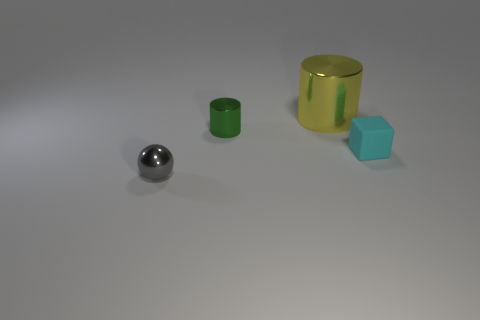Do the yellow thing and the green metal thing have the same shape?
Your answer should be very brief. Yes. Is the number of tiny things that are behind the cyan block less than the number of large yellow metallic things that are in front of the green cylinder?
Make the answer very short. No. What number of big yellow metal cylinders are left of the yellow cylinder?
Provide a succinct answer. 0. There is a tiny shiny object behind the small metal ball; is it the same shape as the thing to the right of the yellow shiny object?
Your answer should be compact. No. The big cylinder behind the small thing behind the tiny thing that is on the right side of the big shiny cylinder is made of what material?
Your response must be concise. Metal. What is the material of the tiny thing on the right side of the big yellow metallic object that is behind the tiny cyan rubber block?
Offer a very short reply. Rubber. Are there fewer small green cylinders that are left of the ball than small cylinders?
Give a very brief answer. Yes. What is the shape of the shiny thing in front of the cyan cube?
Ensure brevity in your answer.  Sphere. Does the shiny sphere have the same size as the cylinder that is in front of the yellow metallic object?
Your answer should be very brief. Yes. Are there any red objects made of the same material as the cyan cube?
Provide a short and direct response. No. 